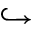Convert formula to latex. <formula><loc_0><loc_0><loc_500><loc_500>\hookrightarrow</formula> 